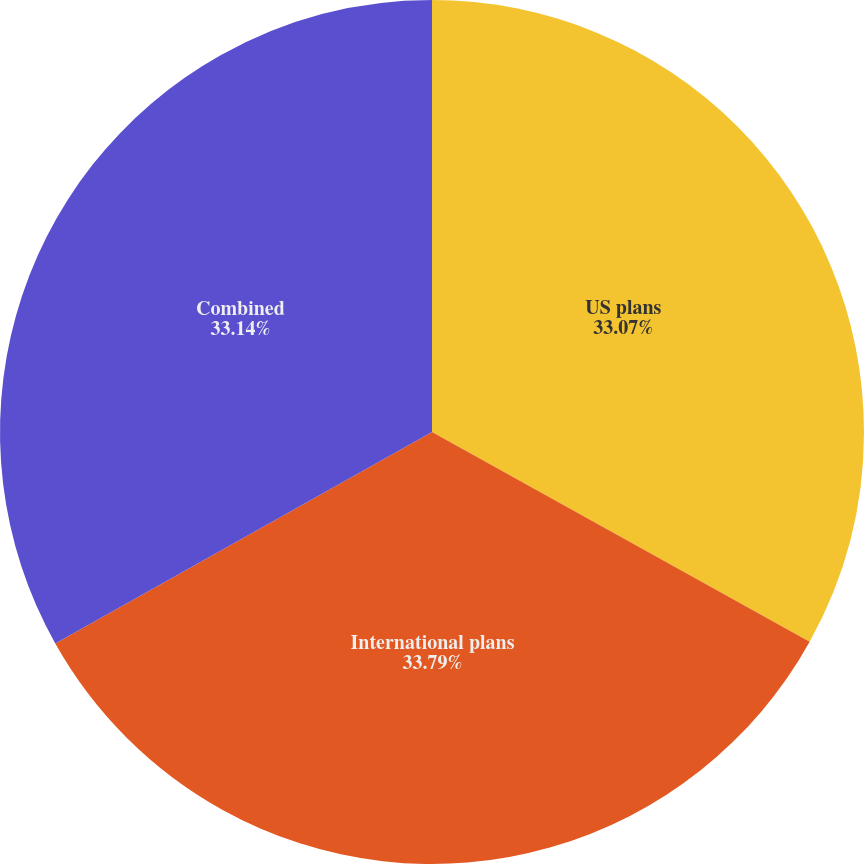<chart> <loc_0><loc_0><loc_500><loc_500><pie_chart><fcel>US plans<fcel>International plans<fcel>Combined<nl><fcel>33.07%<fcel>33.79%<fcel>33.14%<nl></chart> 